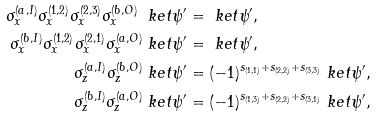Convert formula to latex. <formula><loc_0><loc_0><loc_500><loc_500>\sigma _ { x } ^ { ( a , I ) } \sigma _ { x } ^ { ( 1 , 2 ) } \sigma _ { x } ^ { ( 2 , 3 ) } \sigma _ { x } ^ { ( b , O ) } \ k e t { \psi ^ { \prime } } & = \ k e t { \psi ^ { \prime } } , \\ \sigma _ { x } ^ { ( b , I ) } \sigma _ { x } ^ { ( 1 , 2 ) } \sigma _ { x } ^ { ( 2 , 1 ) } \sigma _ { x } ^ { ( a , O ) } \ k e t { \psi ^ { \prime } } & = \ k e t { \psi ^ { \prime } } , \\ \sigma _ { z } ^ { ( a , I ) } \sigma _ { z } ^ { ( b , O ) } \ k e t { \psi ^ { \prime } } & = ( - 1 ) ^ { s _ { ( 1 , 1 ) } + s _ { ( 2 , 2 ) } + s _ { ( 3 , 3 ) } } \ k e t { \psi ^ { \prime } } , \\ \sigma _ { z } ^ { ( b , I ) } \sigma _ { z } ^ { ( a , O ) } \ k e t { \psi ^ { \prime } } & = ( - 1 ) ^ { s _ { ( 1 , 3 ) } + s _ { ( 2 , 2 ) } + s _ { ( 3 , 1 ) } } \ k e t { \psi ^ { \prime } } ,</formula> 